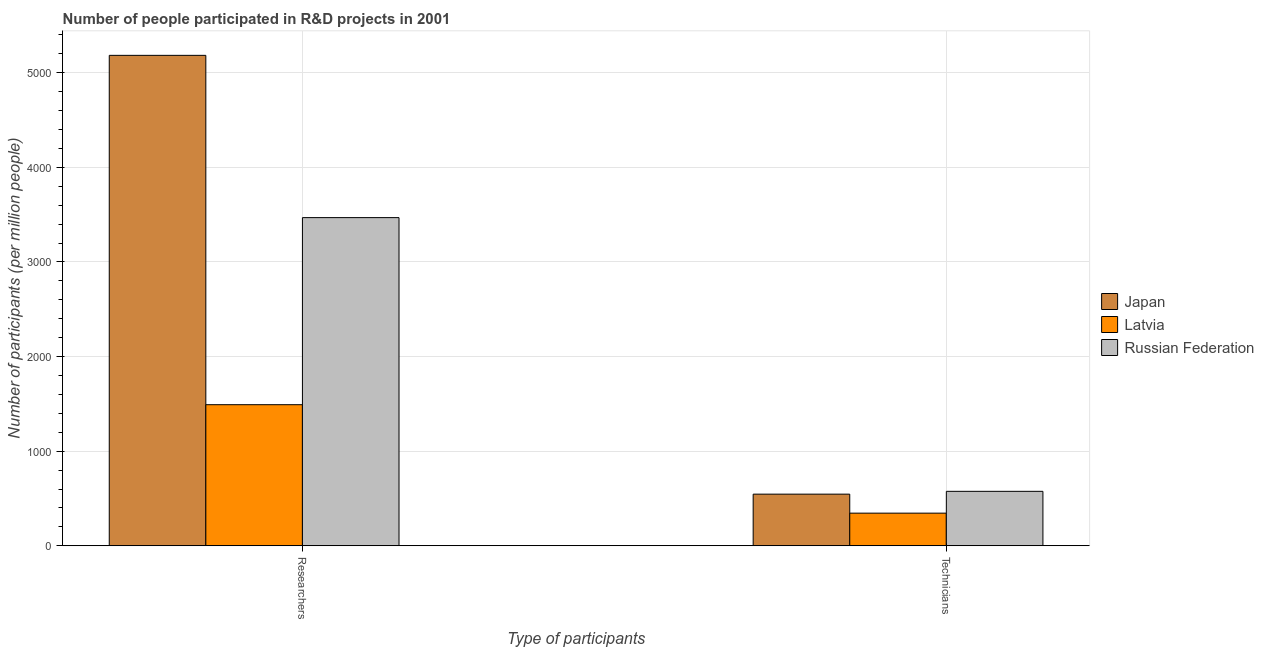How many different coloured bars are there?
Offer a very short reply. 3. How many groups of bars are there?
Give a very brief answer. 2. Are the number of bars per tick equal to the number of legend labels?
Your answer should be very brief. Yes. How many bars are there on the 1st tick from the right?
Ensure brevity in your answer.  3. What is the label of the 2nd group of bars from the left?
Provide a succinct answer. Technicians. What is the number of researchers in Latvia?
Give a very brief answer. 1491.17. Across all countries, what is the maximum number of researchers?
Offer a very short reply. 5183.76. Across all countries, what is the minimum number of technicians?
Provide a short and direct response. 344.97. In which country was the number of technicians maximum?
Offer a very short reply. Russian Federation. In which country was the number of technicians minimum?
Give a very brief answer. Latvia. What is the total number of researchers in the graph?
Your answer should be very brief. 1.01e+04. What is the difference between the number of technicians in Japan and that in Latvia?
Ensure brevity in your answer.  200.81. What is the difference between the number of technicians in Latvia and the number of researchers in Russian Federation?
Keep it short and to the point. -3123.59. What is the average number of researchers per country?
Your answer should be very brief. 3381.16. What is the difference between the number of researchers and number of technicians in Latvia?
Your response must be concise. 1146.2. In how many countries, is the number of technicians greater than 4800 ?
Offer a terse response. 0. What is the ratio of the number of technicians in Japan to that in Latvia?
Your answer should be compact. 1.58. What does the 3rd bar from the right in Technicians represents?
Offer a very short reply. Japan. How many bars are there?
Your response must be concise. 6. How many countries are there in the graph?
Your response must be concise. 3. Does the graph contain any zero values?
Offer a terse response. No. Where does the legend appear in the graph?
Your response must be concise. Center right. How are the legend labels stacked?
Give a very brief answer. Vertical. What is the title of the graph?
Your answer should be very brief. Number of people participated in R&D projects in 2001. What is the label or title of the X-axis?
Offer a very short reply. Type of participants. What is the label or title of the Y-axis?
Provide a short and direct response. Number of participants (per million people). What is the Number of participants (per million people) of Japan in Researchers?
Offer a terse response. 5183.76. What is the Number of participants (per million people) of Latvia in Researchers?
Offer a terse response. 1491.17. What is the Number of participants (per million people) in Russian Federation in Researchers?
Offer a very short reply. 3468.55. What is the Number of participants (per million people) of Japan in Technicians?
Provide a short and direct response. 545.78. What is the Number of participants (per million people) of Latvia in Technicians?
Make the answer very short. 344.97. What is the Number of participants (per million people) in Russian Federation in Technicians?
Offer a terse response. 575.47. Across all Type of participants, what is the maximum Number of participants (per million people) of Japan?
Provide a succinct answer. 5183.76. Across all Type of participants, what is the maximum Number of participants (per million people) of Latvia?
Provide a short and direct response. 1491.17. Across all Type of participants, what is the maximum Number of participants (per million people) in Russian Federation?
Give a very brief answer. 3468.55. Across all Type of participants, what is the minimum Number of participants (per million people) of Japan?
Provide a short and direct response. 545.78. Across all Type of participants, what is the minimum Number of participants (per million people) in Latvia?
Your answer should be compact. 344.97. Across all Type of participants, what is the minimum Number of participants (per million people) of Russian Federation?
Your answer should be compact. 575.47. What is the total Number of participants (per million people) of Japan in the graph?
Keep it short and to the point. 5729.54. What is the total Number of participants (per million people) of Latvia in the graph?
Offer a very short reply. 1836.13. What is the total Number of participants (per million people) of Russian Federation in the graph?
Offer a terse response. 4044.02. What is the difference between the Number of participants (per million people) of Japan in Researchers and that in Technicians?
Make the answer very short. 4637.99. What is the difference between the Number of participants (per million people) of Latvia in Researchers and that in Technicians?
Offer a very short reply. 1146.2. What is the difference between the Number of participants (per million people) in Russian Federation in Researchers and that in Technicians?
Keep it short and to the point. 2893.08. What is the difference between the Number of participants (per million people) of Japan in Researchers and the Number of participants (per million people) of Latvia in Technicians?
Keep it short and to the point. 4838.8. What is the difference between the Number of participants (per million people) of Japan in Researchers and the Number of participants (per million people) of Russian Federation in Technicians?
Your answer should be compact. 4608.29. What is the difference between the Number of participants (per million people) of Latvia in Researchers and the Number of participants (per million people) of Russian Federation in Technicians?
Your answer should be compact. 915.7. What is the average Number of participants (per million people) in Japan per Type of participants?
Give a very brief answer. 2864.77. What is the average Number of participants (per million people) in Latvia per Type of participants?
Provide a succinct answer. 918.07. What is the average Number of participants (per million people) of Russian Federation per Type of participants?
Provide a succinct answer. 2022.01. What is the difference between the Number of participants (per million people) of Japan and Number of participants (per million people) of Latvia in Researchers?
Provide a succinct answer. 3692.6. What is the difference between the Number of participants (per million people) of Japan and Number of participants (per million people) of Russian Federation in Researchers?
Keep it short and to the point. 1715.21. What is the difference between the Number of participants (per million people) in Latvia and Number of participants (per million people) in Russian Federation in Researchers?
Offer a very short reply. -1977.39. What is the difference between the Number of participants (per million people) of Japan and Number of participants (per million people) of Latvia in Technicians?
Give a very brief answer. 200.81. What is the difference between the Number of participants (per million people) in Japan and Number of participants (per million people) in Russian Federation in Technicians?
Your answer should be very brief. -29.69. What is the difference between the Number of participants (per million people) of Latvia and Number of participants (per million people) of Russian Federation in Technicians?
Keep it short and to the point. -230.5. What is the ratio of the Number of participants (per million people) in Japan in Researchers to that in Technicians?
Offer a terse response. 9.5. What is the ratio of the Number of participants (per million people) in Latvia in Researchers to that in Technicians?
Offer a very short reply. 4.32. What is the ratio of the Number of participants (per million people) of Russian Federation in Researchers to that in Technicians?
Your answer should be compact. 6.03. What is the difference between the highest and the second highest Number of participants (per million people) in Japan?
Provide a succinct answer. 4637.99. What is the difference between the highest and the second highest Number of participants (per million people) in Latvia?
Offer a very short reply. 1146.2. What is the difference between the highest and the second highest Number of participants (per million people) of Russian Federation?
Your answer should be compact. 2893.08. What is the difference between the highest and the lowest Number of participants (per million people) of Japan?
Your response must be concise. 4637.99. What is the difference between the highest and the lowest Number of participants (per million people) of Latvia?
Your response must be concise. 1146.2. What is the difference between the highest and the lowest Number of participants (per million people) in Russian Federation?
Provide a succinct answer. 2893.08. 